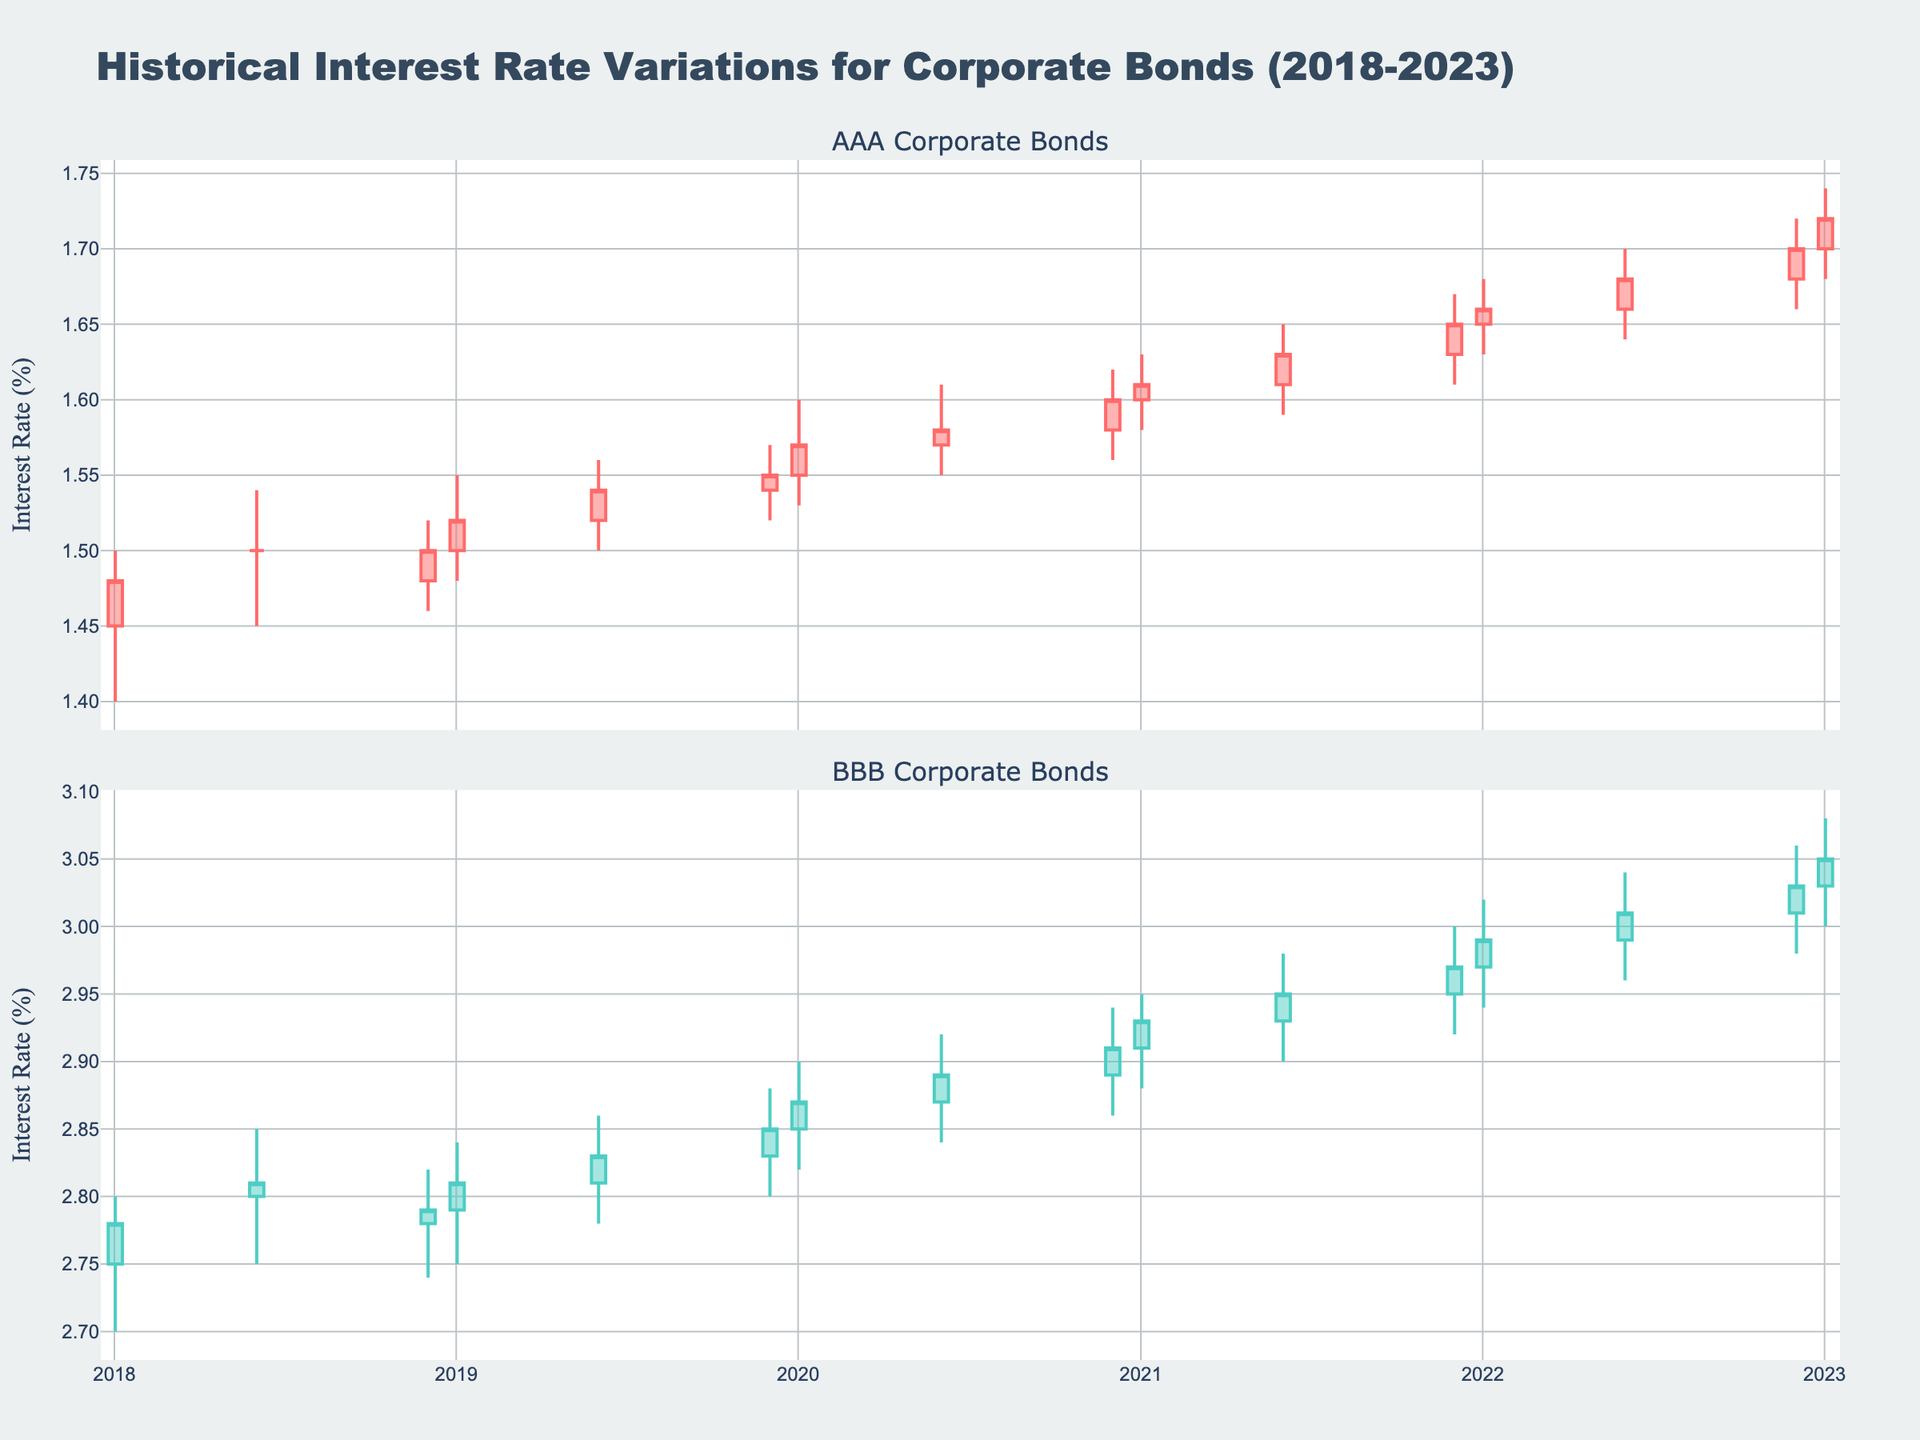What is the title of the figure? The title is displayed at the top of the figure, stating the main subject of the plot.
Answer: 'Historical Interest Rate Variations for Corporate Bonds (2018-2023)' How many main subplots are there? By observing the distinct sections which are separated by subplot titles, we can count two main subplots.
Answer: 2 Which subplot shows interest rates for AAA-rated bonds? By looking at the subplot titles, the one that mentions 'AAA Corporate Bonds' corresponds to that rating.
Answer: The top subplot Between January 2020 and January 2021, did the interest rate for BBB-rated bonds ever decrease? By checking the candlestick bars for BBB-rated bonds in the specified time range, we see if the closing value was lower than the opening value.
Answer: No Which rating saw a higher ultimate interest rate in January 2023? Compare the closing values for AAA and BBB bonds in January 2023. Both subplot closing value comparison shows BBB has a higher value.
Answer: BBB What is the color used for increasing interest rates for AAA-rated bonds? Observing the candlestick colors, the increasing rate for AAA is depicted in a unique primary color.
Answer: A teal-like color How did the interest rate for AAA-rated bonds change between December 2019 and January 2020? Compare the closing rate of December 2019 with the closing rate of January 2020 by looking at the top subplot.
Answer: Increased In June 2022, what is the range between the highest and the lowest interest rate for BBB-rated bonds? Find and subtract the low value from the high value on the respective candlestick for BBB bonds in June 2022.
Answer: \(3.04 - 2.96 = 0.08\) Which month shows the highest interest rate for AAA-rated bonds over the years? Identify the highest value of all the candlesticks' 'high' values in the top subplot.
Answer: January 2023 Comparing June 2018 to January 2023, how much did the interest rate for AAA-rated bonds improve? Subtract the closing value in June 2018 from the closing value in January 2023 on the top subplot.
Answer: \(1.72 - 1.50 = 0.22\) 